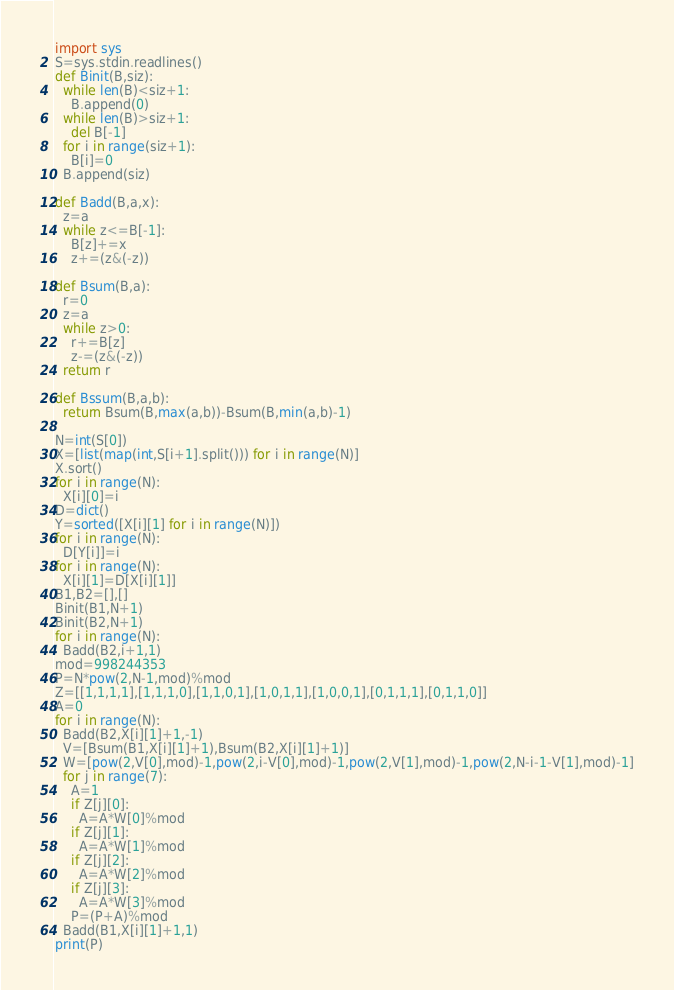Convert code to text. <code><loc_0><loc_0><loc_500><loc_500><_Python_>import sys
S=sys.stdin.readlines()
def Binit(B,siz):
  while len(B)<siz+1:
    B.append(0)
  while len(B)>siz+1:
    del B[-1]
  for i in range(siz+1):
    B[i]=0
  B.append(siz)

def Badd(B,a,x):
  z=a
  while z<=B[-1]:
    B[z]+=x
    z+=(z&(-z))

def Bsum(B,a):
  r=0
  z=a
  while z>0:
    r+=B[z]
    z-=(z&(-z))
  return r

def Bssum(B,a,b):
  return Bsum(B,max(a,b))-Bsum(B,min(a,b)-1)

N=int(S[0])
X=[list(map(int,S[i+1].split())) for i in range(N)]
X.sort()
for i in range(N):
  X[i][0]=i
D=dict()
Y=sorted([X[i][1] for i in range(N)])
for i in range(N):
  D[Y[i]]=i
for i in range(N):
  X[i][1]=D[X[i][1]]
B1,B2=[],[]
Binit(B1,N+1)
Binit(B2,N+1)
for i in range(N):
  Badd(B2,i+1,1)
mod=998244353
P=N*pow(2,N-1,mod)%mod
Z=[[1,1,1,1],[1,1,1,0],[1,1,0,1],[1,0,1,1],[1,0,0,1],[0,1,1,1],[0,1,1,0]]
A=0
for i in range(N):
  Badd(B2,X[i][1]+1,-1)
  V=[Bsum(B1,X[i][1]+1),Bsum(B2,X[i][1]+1)]
  W=[pow(2,V[0],mod)-1,pow(2,i-V[0],mod)-1,pow(2,V[1],mod)-1,pow(2,N-i-1-V[1],mod)-1]
  for j in range(7):
    A=1
    if Z[j][0]:
      A=A*W[0]%mod
    if Z[j][1]:
      A=A*W[1]%mod
    if Z[j][2]:
      A=A*W[2]%mod
    if Z[j][3]:
      A=A*W[3]%mod
    P=(P+A)%mod
  Badd(B1,X[i][1]+1,1)
print(P)</code> 